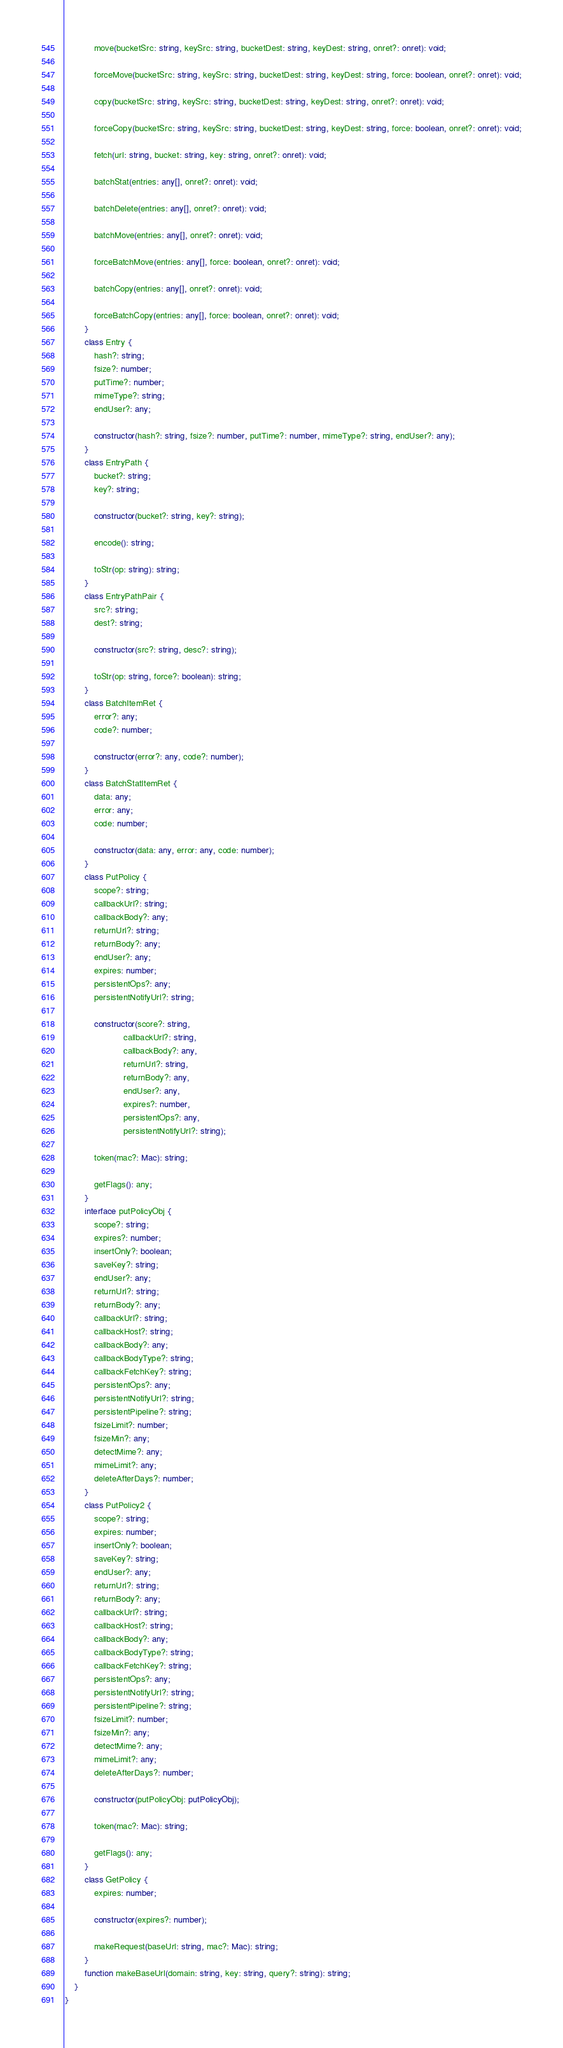<code> <loc_0><loc_0><loc_500><loc_500><_TypeScript_>            move(bucketSrc: string, keySrc: string, bucketDest: string, keyDest: string, onret?: onret): void;

            forceMove(bucketSrc: string, keySrc: string, bucketDest: string, keyDest: string, force: boolean, onret?: onret): void;

            copy(bucketSrc: string, keySrc: string, bucketDest: string, keyDest: string, onret?: onret): void;

            forceCopy(bucketSrc: string, keySrc: string, bucketDest: string, keyDest: string, force: boolean, onret?: onret): void;

            fetch(url: string, bucket: string, key: string, onret?: onret): void;

            batchStat(entries: any[], onret?: onret): void;

            batchDelete(entries: any[], onret?: onret): void;

            batchMove(entries: any[], onret?: onret): void;

            forceBatchMove(entries: any[], force: boolean, onret?: onret): void;

            batchCopy(entries: any[], onret?: onret): void;

            forceBatchCopy(entries: any[], force: boolean, onret?: onret): void;
        }
        class Entry {
            hash?: string;
            fsize?: number;
            putTime?: number;
            mimeType?: string;
            endUser?: any;

            constructor(hash?: string, fsize?: number, putTime?: number, mimeType?: string, endUser?: any);
        }
        class EntryPath {
            bucket?: string;
            key?: string;

            constructor(bucket?: string, key?: string);

            encode(): string;

            toStr(op: string): string;
        }
        class EntryPathPair {
            src?: string;
            dest?: string;

            constructor(src?: string, desc?: string);

            toStr(op: string, force?: boolean): string;
        }
        class BatchItemRet {
            error?: any;
            code?: number;

            constructor(error?: any, code?: number);
        }
        class BatchStatItemRet {
            data: any;
            error: any;
            code: number;

            constructor(data: any, error: any, code: number);
        }
        class PutPolicy {
            scope?: string;
            callbackUrl?: string;
            callbackBody?: any;
            returnUrl?: string;
            returnBody?: any;
            endUser?: any;
            expires: number;
            persistentOps?: any;
            persistentNotifyUrl?: string;

            constructor(score?: string,
                        callbackUrl?: string,
                        callbackBody?: any,
                        returnUrl?: string,
                        returnBody?: any,
                        endUser?: any,
                        expires?: number,
                        persistentOps?: any,
                        persistentNotifyUrl?: string);

            token(mac?: Mac): string;

            getFlags(): any;
        }
        interface putPolicyObj {
            scope?: string;
            expires?: number;
            insertOnly?: boolean;
            saveKey?: string;
            endUser?: any;
            returnUrl?: string;
            returnBody?: any;
            callbackUrl?: string;
            callbackHost?: string;
            callbackBody?: any;
            callbackBodyType?: string;
            callbackFetchKey?: string;
            persistentOps?: any;
            persistentNotifyUrl?: string;
            persistentPipeline?: string;
            fsizeLimit?: number;
            fsizeMin?: any;
            detectMime?: any;
            mimeLimit?: any;
            deleteAfterDays?: number;
        }
        class PutPolicy2 {
            scope?: string;
            expires: number;
            insertOnly?: boolean;
            saveKey?: string;
            endUser?: any;
            returnUrl?: string;
            returnBody?: any;
            callbackUrl?: string;
            callbackHost?: string;
            callbackBody?: any;
            callbackBodyType?: string;
            callbackFetchKey?: string;
            persistentOps?: any;
            persistentNotifyUrl?: string;
            persistentPipeline?: string;
            fsizeLimit?: number;
            fsizeMin?: any;
            detectMime?: any;
            mimeLimit?: any;
            deleteAfterDays?: number;

            constructor(putPolicyObj: putPolicyObj);

            token(mac?: Mac): string;

            getFlags(): any;
        }
        class GetPolicy {
            expires: number;

            constructor(expires?: number);

            makeRequest(baseUrl: string, mac?: Mac): string;
        }
        function makeBaseUrl(domain: string, key: string, query?: string): string;
    }
}
</code> 